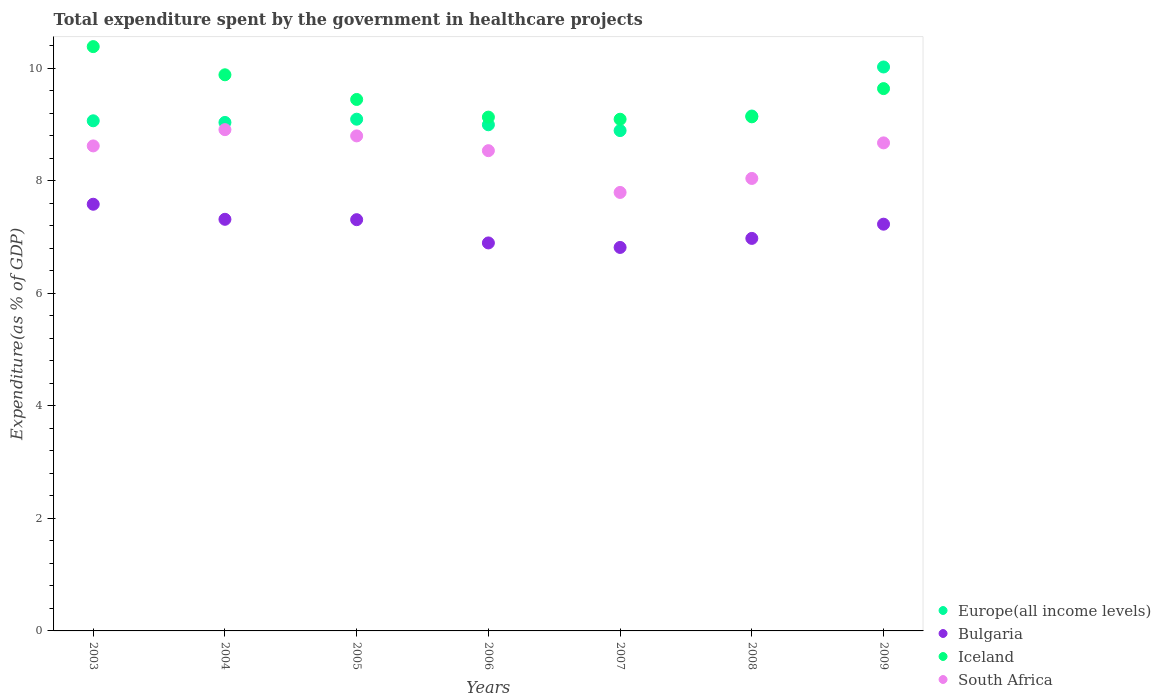How many different coloured dotlines are there?
Provide a succinct answer. 4. Is the number of dotlines equal to the number of legend labels?
Give a very brief answer. Yes. What is the total expenditure spent by the government in healthcare projects in Europe(all income levels) in 2005?
Your answer should be compact. 9.09. Across all years, what is the maximum total expenditure spent by the government in healthcare projects in Iceland?
Your response must be concise. 10.38. Across all years, what is the minimum total expenditure spent by the government in healthcare projects in South Africa?
Your response must be concise. 7.79. In which year was the total expenditure spent by the government in healthcare projects in Bulgaria maximum?
Ensure brevity in your answer.  2003. What is the total total expenditure spent by the government in healthcare projects in South Africa in the graph?
Provide a succinct answer. 59.35. What is the difference between the total expenditure spent by the government in healthcare projects in Europe(all income levels) in 2004 and that in 2008?
Your answer should be compact. -0.11. What is the difference between the total expenditure spent by the government in healthcare projects in South Africa in 2005 and the total expenditure spent by the government in healthcare projects in Iceland in 2009?
Provide a succinct answer. -0.84. What is the average total expenditure spent by the government in healthcare projects in South Africa per year?
Your response must be concise. 8.48. In the year 2007, what is the difference between the total expenditure spent by the government in healthcare projects in Bulgaria and total expenditure spent by the government in healthcare projects in Iceland?
Ensure brevity in your answer.  -2.28. In how many years, is the total expenditure spent by the government in healthcare projects in Iceland greater than 6.4 %?
Provide a short and direct response. 7. What is the ratio of the total expenditure spent by the government in healthcare projects in Europe(all income levels) in 2003 to that in 2005?
Provide a succinct answer. 1. What is the difference between the highest and the second highest total expenditure spent by the government in healthcare projects in Europe(all income levels)?
Ensure brevity in your answer.  0.87. What is the difference between the highest and the lowest total expenditure spent by the government in healthcare projects in Bulgaria?
Offer a terse response. 0.77. In how many years, is the total expenditure spent by the government in healthcare projects in Iceland greater than the average total expenditure spent by the government in healthcare projects in Iceland taken over all years?
Offer a very short reply. 3. Is it the case that in every year, the sum of the total expenditure spent by the government in healthcare projects in Bulgaria and total expenditure spent by the government in healthcare projects in Iceland  is greater than the sum of total expenditure spent by the government in healthcare projects in Europe(all income levels) and total expenditure spent by the government in healthcare projects in South Africa?
Offer a very short reply. No. Does the total expenditure spent by the government in healthcare projects in Europe(all income levels) monotonically increase over the years?
Provide a short and direct response. No. Is the total expenditure spent by the government in healthcare projects in Europe(all income levels) strictly greater than the total expenditure spent by the government in healthcare projects in South Africa over the years?
Your answer should be very brief. Yes. Is the total expenditure spent by the government in healthcare projects in Bulgaria strictly less than the total expenditure spent by the government in healthcare projects in South Africa over the years?
Make the answer very short. Yes. What is the difference between two consecutive major ticks on the Y-axis?
Offer a terse response. 2. Does the graph contain any zero values?
Offer a terse response. No. Where does the legend appear in the graph?
Your answer should be very brief. Bottom right. What is the title of the graph?
Your response must be concise. Total expenditure spent by the government in healthcare projects. Does "Latin America(all income levels)" appear as one of the legend labels in the graph?
Your answer should be very brief. No. What is the label or title of the X-axis?
Your answer should be compact. Years. What is the label or title of the Y-axis?
Make the answer very short. Expenditure(as % of GDP). What is the Expenditure(as % of GDP) of Europe(all income levels) in 2003?
Offer a very short reply. 9.06. What is the Expenditure(as % of GDP) of Bulgaria in 2003?
Ensure brevity in your answer.  7.58. What is the Expenditure(as % of GDP) in Iceland in 2003?
Ensure brevity in your answer.  10.38. What is the Expenditure(as % of GDP) of South Africa in 2003?
Ensure brevity in your answer.  8.62. What is the Expenditure(as % of GDP) in Europe(all income levels) in 2004?
Your answer should be compact. 9.03. What is the Expenditure(as % of GDP) of Bulgaria in 2004?
Offer a terse response. 7.31. What is the Expenditure(as % of GDP) in Iceland in 2004?
Ensure brevity in your answer.  9.88. What is the Expenditure(as % of GDP) of South Africa in 2004?
Offer a very short reply. 8.91. What is the Expenditure(as % of GDP) of Europe(all income levels) in 2005?
Provide a succinct answer. 9.09. What is the Expenditure(as % of GDP) of Bulgaria in 2005?
Provide a short and direct response. 7.31. What is the Expenditure(as % of GDP) in Iceland in 2005?
Provide a short and direct response. 9.44. What is the Expenditure(as % of GDP) in South Africa in 2005?
Provide a succinct answer. 8.8. What is the Expenditure(as % of GDP) of Europe(all income levels) in 2006?
Offer a terse response. 8.99. What is the Expenditure(as % of GDP) of Bulgaria in 2006?
Give a very brief answer. 6.89. What is the Expenditure(as % of GDP) of Iceland in 2006?
Provide a short and direct response. 9.13. What is the Expenditure(as % of GDP) in South Africa in 2006?
Give a very brief answer. 8.53. What is the Expenditure(as % of GDP) of Europe(all income levels) in 2007?
Your answer should be compact. 8.89. What is the Expenditure(as % of GDP) in Bulgaria in 2007?
Keep it short and to the point. 6.81. What is the Expenditure(as % of GDP) of Iceland in 2007?
Make the answer very short. 9.09. What is the Expenditure(as % of GDP) in South Africa in 2007?
Offer a terse response. 7.79. What is the Expenditure(as % of GDP) in Europe(all income levels) in 2008?
Provide a succinct answer. 9.15. What is the Expenditure(as % of GDP) in Bulgaria in 2008?
Your answer should be very brief. 6.97. What is the Expenditure(as % of GDP) in Iceland in 2008?
Ensure brevity in your answer.  9.13. What is the Expenditure(as % of GDP) in South Africa in 2008?
Your answer should be compact. 8.04. What is the Expenditure(as % of GDP) of Europe(all income levels) in 2009?
Provide a succinct answer. 10.02. What is the Expenditure(as % of GDP) of Bulgaria in 2009?
Your answer should be very brief. 7.23. What is the Expenditure(as % of GDP) of Iceland in 2009?
Offer a very short reply. 9.64. What is the Expenditure(as % of GDP) in South Africa in 2009?
Make the answer very short. 8.67. Across all years, what is the maximum Expenditure(as % of GDP) in Europe(all income levels)?
Your answer should be compact. 10.02. Across all years, what is the maximum Expenditure(as % of GDP) in Bulgaria?
Offer a very short reply. 7.58. Across all years, what is the maximum Expenditure(as % of GDP) of Iceland?
Ensure brevity in your answer.  10.38. Across all years, what is the maximum Expenditure(as % of GDP) in South Africa?
Keep it short and to the point. 8.91. Across all years, what is the minimum Expenditure(as % of GDP) of Europe(all income levels)?
Ensure brevity in your answer.  8.89. Across all years, what is the minimum Expenditure(as % of GDP) of Bulgaria?
Provide a short and direct response. 6.81. Across all years, what is the minimum Expenditure(as % of GDP) of Iceland?
Provide a succinct answer. 9.09. Across all years, what is the minimum Expenditure(as % of GDP) in South Africa?
Give a very brief answer. 7.79. What is the total Expenditure(as % of GDP) of Europe(all income levels) in the graph?
Your answer should be compact. 64.24. What is the total Expenditure(as % of GDP) in Bulgaria in the graph?
Your answer should be compact. 50.11. What is the total Expenditure(as % of GDP) of Iceland in the graph?
Give a very brief answer. 66.7. What is the total Expenditure(as % of GDP) in South Africa in the graph?
Provide a succinct answer. 59.35. What is the difference between the Expenditure(as % of GDP) of Europe(all income levels) in 2003 and that in 2004?
Your answer should be very brief. 0.03. What is the difference between the Expenditure(as % of GDP) of Bulgaria in 2003 and that in 2004?
Give a very brief answer. 0.27. What is the difference between the Expenditure(as % of GDP) in Iceland in 2003 and that in 2004?
Your answer should be compact. 0.5. What is the difference between the Expenditure(as % of GDP) in South Africa in 2003 and that in 2004?
Keep it short and to the point. -0.29. What is the difference between the Expenditure(as % of GDP) in Europe(all income levels) in 2003 and that in 2005?
Offer a terse response. -0.03. What is the difference between the Expenditure(as % of GDP) of Bulgaria in 2003 and that in 2005?
Offer a terse response. 0.27. What is the difference between the Expenditure(as % of GDP) of Iceland in 2003 and that in 2005?
Give a very brief answer. 0.94. What is the difference between the Expenditure(as % of GDP) of South Africa in 2003 and that in 2005?
Offer a terse response. -0.18. What is the difference between the Expenditure(as % of GDP) in Europe(all income levels) in 2003 and that in 2006?
Give a very brief answer. 0.07. What is the difference between the Expenditure(as % of GDP) in Bulgaria in 2003 and that in 2006?
Your response must be concise. 0.69. What is the difference between the Expenditure(as % of GDP) of Iceland in 2003 and that in 2006?
Keep it short and to the point. 1.25. What is the difference between the Expenditure(as % of GDP) of South Africa in 2003 and that in 2006?
Your answer should be very brief. 0.08. What is the difference between the Expenditure(as % of GDP) in Europe(all income levels) in 2003 and that in 2007?
Ensure brevity in your answer.  0.17. What is the difference between the Expenditure(as % of GDP) in Bulgaria in 2003 and that in 2007?
Provide a short and direct response. 0.77. What is the difference between the Expenditure(as % of GDP) of Iceland in 2003 and that in 2007?
Give a very brief answer. 1.29. What is the difference between the Expenditure(as % of GDP) in South Africa in 2003 and that in 2007?
Offer a very short reply. 0.83. What is the difference between the Expenditure(as % of GDP) in Europe(all income levels) in 2003 and that in 2008?
Offer a very short reply. -0.08. What is the difference between the Expenditure(as % of GDP) of Bulgaria in 2003 and that in 2008?
Ensure brevity in your answer.  0.61. What is the difference between the Expenditure(as % of GDP) of Iceland in 2003 and that in 2008?
Provide a short and direct response. 1.25. What is the difference between the Expenditure(as % of GDP) in South Africa in 2003 and that in 2008?
Your response must be concise. 0.58. What is the difference between the Expenditure(as % of GDP) of Europe(all income levels) in 2003 and that in 2009?
Make the answer very short. -0.96. What is the difference between the Expenditure(as % of GDP) in Bulgaria in 2003 and that in 2009?
Your answer should be compact. 0.35. What is the difference between the Expenditure(as % of GDP) of Iceland in 2003 and that in 2009?
Give a very brief answer. 0.75. What is the difference between the Expenditure(as % of GDP) of South Africa in 2003 and that in 2009?
Offer a very short reply. -0.05. What is the difference between the Expenditure(as % of GDP) in Europe(all income levels) in 2004 and that in 2005?
Provide a short and direct response. -0.06. What is the difference between the Expenditure(as % of GDP) of Bulgaria in 2004 and that in 2005?
Provide a succinct answer. 0.01. What is the difference between the Expenditure(as % of GDP) of Iceland in 2004 and that in 2005?
Provide a succinct answer. 0.44. What is the difference between the Expenditure(as % of GDP) of South Africa in 2004 and that in 2005?
Keep it short and to the point. 0.11. What is the difference between the Expenditure(as % of GDP) in Europe(all income levels) in 2004 and that in 2006?
Provide a short and direct response. 0.04. What is the difference between the Expenditure(as % of GDP) in Bulgaria in 2004 and that in 2006?
Your answer should be compact. 0.42. What is the difference between the Expenditure(as % of GDP) of Iceland in 2004 and that in 2006?
Ensure brevity in your answer.  0.75. What is the difference between the Expenditure(as % of GDP) of South Africa in 2004 and that in 2006?
Your response must be concise. 0.37. What is the difference between the Expenditure(as % of GDP) in Europe(all income levels) in 2004 and that in 2007?
Offer a terse response. 0.14. What is the difference between the Expenditure(as % of GDP) of Bulgaria in 2004 and that in 2007?
Your response must be concise. 0.5. What is the difference between the Expenditure(as % of GDP) in Iceland in 2004 and that in 2007?
Offer a terse response. 0.79. What is the difference between the Expenditure(as % of GDP) of South Africa in 2004 and that in 2007?
Your answer should be compact. 1.12. What is the difference between the Expenditure(as % of GDP) of Europe(all income levels) in 2004 and that in 2008?
Give a very brief answer. -0.11. What is the difference between the Expenditure(as % of GDP) in Bulgaria in 2004 and that in 2008?
Ensure brevity in your answer.  0.34. What is the difference between the Expenditure(as % of GDP) in Iceland in 2004 and that in 2008?
Keep it short and to the point. 0.75. What is the difference between the Expenditure(as % of GDP) in South Africa in 2004 and that in 2008?
Your response must be concise. 0.87. What is the difference between the Expenditure(as % of GDP) in Europe(all income levels) in 2004 and that in 2009?
Offer a terse response. -0.99. What is the difference between the Expenditure(as % of GDP) of Bulgaria in 2004 and that in 2009?
Your response must be concise. 0.09. What is the difference between the Expenditure(as % of GDP) in Iceland in 2004 and that in 2009?
Provide a short and direct response. 0.25. What is the difference between the Expenditure(as % of GDP) of South Africa in 2004 and that in 2009?
Ensure brevity in your answer.  0.23. What is the difference between the Expenditure(as % of GDP) of Europe(all income levels) in 2005 and that in 2006?
Provide a succinct answer. 0.1. What is the difference between the Expenditure(as % of GDP) of Bulgaria in 2005 and that in 2006?
Offer a terse response. 0.41. What is the difference between the Expenditure(as % of GDP) in Iceland in 2005 and that in 2006?
Give a very brief answer. 0.31. What is the difference between the Expenditure(as % of GDP) of South Africa in 2005 and that in 2006?
Offer a terse response. 0.26. What is the difference between the Expenditure(as % of GDP) of Europe(all income levels) in 2005 and that in 2007?
Give a very brief answer. 0.2. What is the difference between the Expenditure(as % of GDP) in Bulgaria in 2005 and that in 2007?
Provide a short and direct response. 0.49. What is the difference between the Expenditure(as % of GDP) in Iceland in 2005 and that in 2007?
Offer a terse response. 0.35. What is the difference between the Expenditure(as % of GDP) of South Africa in 2005 and that in 2007?
Make the answer very short. 1. What is the difference between the Expenditure(as % of GDP) in Europe(all income levels) in 2005 and that in 2008?
Offer a very short reply. -0.06. What is the difference between the Expenditure(as % of GDP) in Bulgaria in 2005 and that in 2008?
Make the answer very short. 0.33. What is the difference between the Expenditure(as % of GDP) of Iceland in 2005 and that in 2008?
Provide a short and direct response. 0.31. What is the difference between the Expenditure(as % of GDP) in South Africa in 2005 and that in 2008?
Your response must be concise. 0.76. What is the difference between the Expenditure(as % of GDP) in Europe(all income levels) in 2005 and that in 2009?
Ensure brevity in your answer.  -0.93. What is the difference between the Expenditure(as % of GDP) of Iceland in 2005 and that in 2009?
Your response must be concise. -0.19. What is the difference between the Expenditure(as % of GDP) of South Africa in 2005 and that in 2009?
Your response must be concise. 0.12. What is the difference between the Expenditure(as % of GDP) of Europe(all income levels) in 2006 and that in 2007?
Your answer should be very brief. 0.1. What is the difference between the Expenditure(as % of GDP) in Bulgaria in 2006 and that in 2007?
Your answer should be compact. 0.08. What is the difference between the Expenditure(as % of GDP) of Iceland in 2006 and that in 2007?
Keep it short and to the point. 0.04. What is the difference between the Expenditure(as % of GDP) in South Africa in 2006 and that in 2007?
Offer a terse response. 0.74. What is the difference between the Expenditure(as % of GDP) in Europe(all income levels) in 2006 and that in 2008?
Your answer should be very brief. -0.16. What is the difference between the Expenditure(as % of GDP) of Bulgaria in 2006 and that in 2008?
Your response must be concise. -0.08. What is the difference between the Expenditure(as % of GDP) of Iceland in 2006 and that in 2008?
Your response must be concise. -0.01. What is the difference between the Expenditure(as % of GDP) in South Africa in 2006 and that in 2008?
Provide a succinct answer. 0.49. What is the difference between the Expenditure(as % of GDP) of Europe(all income levels) in 2006 and that in 2009?
Ensure brevity in your answer.  -1.03. What is the difference between the Expenditure(as % of GDP) of Iceland in 2006 and that in 2009?
Offer a very short reply. -0.51. What is the difference between the Expenditure(as % of GDP) of South Africa in 2006 and that in 2009?
Offer a very short reply. -0.14. What is the difference between the Expenditure(as % of GDP) in Europe(all income levels) in 2007 and that in 2008?
Give a very brief answer. -0.26. What is the difference between the Expenditure(as % of GDP) in Bulgaria in 2007 and that in 2008?
Make the answer very short. -0.16. What is the difference between the Expenditure(as % of GDP) in Iceland in 2007 and that in 2008?
Your response must be concise. -0.04. What is the difference between the Expenditure(as % of GDP) of South Africa in 2007 and that in 2008?
Offer a very short reply. -0.25. What is the difference between the Expenditure(as % of GDP) in Europe(all income levels) in 2007 and that in 2009?
Keep it short and to the point. -1.13. What is the difference between the Expenditure(as % of GDP) of Bulgaria in 2007 and that in 2009?
Ensure brevity in your answer.  -0.41. What is the difference between the Expenditure(as % of GDP) in Iceland in 2007 and that in 2009?
Offer a terse response. -0.54. What is the difference between the Expenditure(as % of GDP) in South Africa in 2007 and that in 2009?
Make the answer very short. -0.88. What is the difference between the Expenditure(as % of GDP) of Europe(all income levels) in 2008 and that in 2009?
Provide a short and direct response. -0.87. What is the difference between the Expenditure(as % of GDP) in Bulgaria in 2008 and that in 2009?
Offer a terse response. -0.25. What is the difference between the Expenditure(as % of GDP) of Iceland in 2008 and that in 2009?
Provide a short and direct response. -0.5. What is the difference between the Expenditure(as % of GDP) in South Africa in 2008 and that in 2009?
Your response must be concise. -0.63. What is the difference between the Expenditure(as % of GDP) in Europe(all income levels) in 2003 and the Expenditure(as % of GDP) in Bulgaria in 2004?
Provide a short and direct response. 1.75. What is the difference between the Expenditure(as % of GDP) in Europe(all income levels) in 2003 and the Expenditure(as % of GDP) in Iceland in 2004?
Offer a very short reply. -0.82. What is the difference between the Expenditure(as % of GDP) in Europe(all income levels) in 2003 and the Expenditure(as % of GDP) in South Africa in 2004?
Your answer should be compact. 0.16. What is the difference between the Expenditure(as % of GDP) of Bulgaria in 2003 and the Expenditure(as % of GDP) of Iceland in 2004?
Provide a short and direct response. -2.3. What is the difference between the Expenditure(as % of GDP) in Bulgaria in 2003 and the Expenditure(as % of GDP) in South Africa in 2004?
Offer a very short reply. -1.33. What is the difference between the Expenditure(as % of GDP) of Iceland in 2003 and the Expenditure(as % of GDP) of South Africa in 2004?
Ensure brevity in your answer.  1.48. What is the difference between the Expenditure(as % of GDP) of Europe(all income levels) in 2003 and the Expenditure(as % of GDP) of Bulgaria in 2005?
Provide a short and direct response. 1.76. What is the difference between the Expenditure(as % of GDP) in Europe(all income levels) in 2003 and the Expenditure(as % of GDP) in Iceland in 2005?
Provide a short and direct response. -0.38. What is the difference between the Expenditure(as % of GDP) in Europe(all income levels) in 2003 and the Expenditure(as % of GDP) in South Africa in 2005?
Your answer should be very brief. 0.27. What is the difference between the Expenditure(as % of GDP) of Bulgaria in 2003 and the Expenditure(as % of GDP) of Iceland in 2005?
Provide a short and direct response. -1.86. What is the difference between the Expenditure(as % of GDP) of Bulgaria in 2003 and the Expenditure(as % of GDP) of South Africa in 2005?
Your answer should be very brief. -1.21. What is the difference between the Expenditure(as % of GDP) of Iceland in 2003 and the Expenditure(as % of GDP) of South Africa in 2005?
Your response must be concise. 1.59. What is the difference between the Expenditure(as % of GDP) of Europe(all income levels) in 2003 and the Expenditure(as % of GDP) of Bulgaria in 2006?
Make the answer very short. 2.17. What is the difference between the Expenditure(as % of GDP) in Europe(all income levels) in 2003 and the Expenditure(as % of GDP) in Iceland in 2006?
Provide a succinct answer. -0.07. What is the difference between the Expenditure(as % of GDP) of Europe(all income levels) in 2003 and the Expenditure(as % of GDP) of South Africa in 2006?
Make the answer very short. 0.53. What is the difference between the Expenditure(as % of GDP) in Bulgaria in 2003 and the Expenditure(as % of GDP) in Iceland in 2006?
Your answer should be very brief. -1.55. What is the difference between the Expenditure(as % of GDP) of Bulgaria in 2003 and the Expenditure(as % of GDP) of South Africa in 2006?
Your answer should be very brief. -0.95. What is the difference between the Expenditure(as % of GDP) of Iceland in 2003 and the Expenditure(as % of GDP) of South Africa in 2006?
Offer a very short reply. 1.85. What is the difference between the Expenditure(as % of GDP) of Europe(all income levels) in 2003 and the Expenditure(as % of GDP) of Bulgaria in 2007?
Ensure brevity in your answer.  2.25. What is the difference between the Expenditure(as % of GDP) of Europe(all income levels) in 2003 and the Expenditure(as % of GDP) of Iceland in 2007?
Your response must be concise. -0.03. What is the difference between the Expenditure(as % of GDP) of Europe(all income levels) in 2003 and the Expenditure(as % of GDP) of South Africa in 2007?
Your answer should be compact. 1.27. What is the difference between the Expenditure(as % of GDP) in Bulgaria in 2003 and the Expenditure(as % of GDP) in Iceland in 2007?
Provide a succinct answer. -1.51. What is the difference between the Expenditure(as % of GDP) in Bulgaria in 2003 and the Expenditure(as % of GDP) in South Africa in 2007?
Provide a short and direct response. -0.21. What is the difference between the Expenditure(as % of GDP) of Iceland in 2003 and the Expenditure(as % of GDP) of South Africa in 2007?
Give a very brief answer. 2.59. What is the difference between the Expenditure(as % of GDP) of Europe(all income levels) in 2003 and the Expenditure(as % of GDP) of Bulgaria in 2008?
Provide a succinct answer. 2.09. What is the difference between the Expenditure(as % of GDP) of Europe(all income levels) in 2003 and the Expenditure(as % of GDP) of Iceland in 2008?
Offer a terse response. -0.07. What is the difference between the Expenditure(as % of GDP) in Europe(all income levels) in 2003 and the Expenditure(as % of GDP) in South Africa in 2008?
Your answer should be very brief. 1.02. What is the difference between the Expenditure(as % of GDP) of Bulgaria in 2003 and the Expenditure(as % of GDP) of Iceland in 2008?
Offer a very short reply. -1.55. What is the difference between the Expenditure(as % of GDP) of Bulgaria in 2003 and the Expenditure(as % of GDP) of South Africa in 2008?
Give a very brief answer. -0.46. What is the difference between the Expenditure(as % of GDP) of Iceland in 2003 and the Expenditure(as % of GDP) of South Africa in 2008?
Make the answer very short. 2.34. What is the difference between the Expenditure(as % of GDP) of Europe(all income levels) in 2003 and the Expenditure(as % of GDP) of Bulgaria in 2009?
Offer a terse response. 1.84. What is the difference between the Expenditure(as % of GDP) in Europe(all income levels) in 2003 and the Expenditure(as % of GDP) in Iceland in 2009?
Your answer should be very brief. -0.57. What is the difference between the Expenditure(as % of GDP) of Europe(all income levels) in 2003 and the Expenditure(as % of GDP) of South Africa in 2009?
Keep it short and to the point. 0.39. What is the difference between the Expenditure(as % of GDP) in Bulgaria in 2003 and the Expenditure(as % of GDP) in Iceland in 2009?
Keep it short and to the point. -2.05. What is the difference between the Expenditure(as % of GDP) in Bulgaria in 2003 and the Expenditure(as % of GDP) in South Africa in 2009?
Offer a terse response. -1.09. What is the difference between the Expenditure(as % of GDP) of Iceland in 2003 and the Expenditure(as % of GDP) of South Africa in 2009?
Keep it short and to the point. 1.71. What is the difference between the Expenditure(as % of GDP) in Europe(all income levels) in 2004 and the Expenditure(as % of GDP) in Bulgaria in 2005?
Provide a succinct answer. 1.73. What is the difference between the Expenditure(as % of GDP) of Europe(all income levels) in 2004 and the Expenditure(as % of GDP) of Iceland in 2005?
Make the answer very short. -0.41. What is the difference between the Expenditure(as % of GDP) in Europe(all income levels) in 2004 and the Expenditure(as % of GDP) in South Africa in 2005?
Provide a succinct answer. 0.24. What is the difference between the Expenditure(as % of GDP) of Bulgaria in 2004 and the Expenditure(as % of GDP) of Iceland in 2005?
Offer a very short reply. -2.13. What is the difference between the Expenditure(as % of GDP) of Bulgaria in 2004 and the Expenditure(as % of GDP) of South Africa in 2005?
Offer a very short reply. -1.48. What is the difference between the Expenditure(as % of GDP) of Iceland in 2004 and the Expenditure(as % of GDP) of South Africa in 2005?
Ensure brevity in your answer.  1.09. What is the difference between the Expenditure(as % of GDP) in Europe(all income levels) in 2004 and the Expenditure(as % of GDP) in Bulgaria in 2006?
Offer a terse response. 2.14. What is the difference between the Expenditure(as % of GDP) of Europe(all income levels) in 2004 and the Expenditure(as % of GDP) of Iceland in 2006?
Provide a succinct answer. -0.09. What is the difference between the Expenditure(as % of GDP) in Europe(all income levels) in 2004 and the Expenditure(as % of GDP) in South Africa in 2006?
Your answer should be compact. 0.5. What is the difference between the Expenditure(as % of GDP) in Bulgaria in 2004 and the Expenditure(as % of GDP) in Iceland in 2006?
Ensure brevity in your answer.  -1.82. What is the difference between the Expenditure(as % of GDP) in Bulgaria in 2004 and the Expenditure(as % of GDP) in South Africa in 2006?
Keep it short and to the point. -1.22. What is the difference between the Expenditure(as % of GDP) of Iceland in 2004 and the Expenditure(as % of GDP) of South Africa in 2006?
Keep it short and to the point. 1.35. What is the difference between the Expenditure(as % of GDP) in Europe(all income levels) in 2004 and the Expenditure(as % of GDP) in Bulgaria in 2007?
Offer a very short reply. 2.22. What is the difference between the Expenditure(as % of GDP) in Europe(all income levels) in 2004 and the Expenditure(as % of GDP) in Iceland in 2007?
Make the answer very short. -0.06. What is the difference between the Expenditure(as % of GDP) in Europe(all income levels) in 2004 and the Expenditure(as % of GDP) in South Africa in 2007?
Your answer should be compact. 1.24. What is the difference between the Expenditure(as % of GDP) of Bulgaria in 2004 and the Expenditure(as % of GDP) of Iceland in 2007?
Provide a succinct answer. -1.78. What is the difference between the Expenditure(as % of GDP) in Bulgaria in 2004 and the Expenditure(as % of GDP) in South Africa in 2007?
Ensure brevity in your answer.  -0.48. What is the difference between the Expenditure(as % of GDP) in Iceland in 2004 and the Expenditure(as % of GDP) in South Africa in 2007?
Make the answer very short. 2.09. What is the difference between the Expenditure(as % of GDP) of Europe(all income levels) in 2004 and the Expenditure(as % of GDP) of Bulgaria in 2008?
Your response must be concise. 2.06. What is the difference between the Expenditure(as % of GDP) in Europe(all income levels) in 2004 and the Expenditure(as % of GDP) in Iceland in 2008?
Your answer should be very brief. -0.1. What is the difference between the Expenditure(as % of GDP) in Europe(all income levels) in 2004 and the Expenditure(as % of GDP) in South Africa in 2008?
Give a very brief answer. 1. What is the difference between the Expenditure(as % of GDP) of Bulgaria in 2004 and the Expenditure(as % of GDP) of Iceland in 2008?
Offer a terse response. -1.82. What is the difference between the Expenditure(as % of GDP) in Bulgaria in 2004 and the Expenditure(as % of GDP) in South Africa in 2008?
Ensure brevity in your answer.  -0.73. What is the difference between the Expenditure(as % of GDP) of Iceland in 2004 and the Expenditure(as % of GDP) of South Africa in 2008?
Offer a very short reply. 1.84. What is the difference between the Expenditure(as % of GDP) in Europe(all income levels) in 2004 and the Expenditure(as % of GDP) in Bulgaria in 2009?
Your answer should be compact. 1.81. What is the difference between the Expenditure(as % of GDP) in Europe(all income levels) in 2004 and the Expenditure(as % of GDP) in Iceland in 2009?
Make the answer very short. -0.6. What is the difference between the Expenditure(as % of GDP) of Europe(all income levels) in 2004 and the Expenditure(as % of GDP) of South Africa in 2009?
Offer a terse response. 0.36. What is the difference between the Expenditure(as % of GDP) of Bulgaria in 2004 and the Expenditure(as % of GDP) of Iceland in 2009?
Keep it short and to the point. -2.32. What is the difference between the Expenditure(as % of GDP) in Bulgaria in 2004 and the Expenditure(as % of GDP) in South Africa in 2009?
Your answer should be very brief. -1.36. What is the difference between the Expenditure(as % of GDP) in Iceland in 2004 and the Expenditure(as % of GDP) in South Africa in 2009?
Offer a very short reply. 1.21. What is the difference between the Expenditure(as % of GDP) in Europe(all income levels) in 2005 and the Expenditure(as % of GDP) in Bulgaria in 2006?
Your response must be concise. 2.2. What is the difference between the Expenditure(as % of GDP) in Europe(all income levels) in 2005 and the Expenditure(as % of GDP) in Iceland in 2006?
Offer a terse response. -0.04. What is the difference between the Expenditure(as % of GDP) of Europe(all income levels) in 2005 and the Expenditure(as % of GDP) of South Africa in 2006?
Provide a short and direct response. 0.56. What is the difference between the Expenditure(as % of GDP) of Bulgaria in 2005 and the Expenditure(as % of GDP) of Iceland in 2006?
Your answer should be compact. -1.82. What is the difference between the Expenditure(as % of GDP) of Bulgaria in 2005 and the Expenditure(as % of GDP) of South Africa in 2006?
Your answer should be very brief. -1.23. What is the difference between the Expenditure(as % of GDP) of Iceland in 2005 and the Expenditure(as % of GDP) of South Africa in 2006?
Give a very brief answer. 0.91. What is the difference between the Expenditure(as % of GDP) in Europe(all income levels) in 2005 and the Expenditure(as % of GDP) in Bulgaria in 2007?
Ensure brevity in your answer.  2.28. What is the difference between the Expenditure(as % of GDP) of Europe(all income levels) in 2005 and the Expenditure(as % of GDP) of Iceland in 2007?
Offer a very short reply. 0. What is the difference between the Expenditure(as % of GDP) in Europe(all income levels) in 2005 and the Expenditure(as % of GDP) in South Africa in 2007?
Provide a succinct answer. 1.3. What is the difference between the Expenditure(as % of GDP) in Bulgaria in 2005 and the Expenditure(as % of GDP) in Iceland in 2007?
Your response must be concise. -1.78. What is the difference between the Expenditure(as % of GDP) of Bulgaria in 2005 and the Expenditure(as % of GDP) of South Africa in 2007?
Your answer should be compact. -0.48. What is the difference between the Expenditure(as % of GDP) in Iceland in 2005 and the Expenditure(as % of GDP) in South Africa in 2007?
Your response must be concise. 1.65. What is the difference between the Expenditure(as % of GDP) in Europe(all income levels) in 2005 and the Expenditure(as % of GDP) in Bulgaria in 2008?
Keep it short and to the point. 2.12. What is the difference between the Expenditure(as % of GDP) of Europe(all income levels) in 2005 and the Expenditure(as % of GDP) of Iceland in 2008?
Give a very brief answer. -0.04. What is the difference between the Expenditure(as % of GDP) in Europe(all income levels) in 2005 and the Expenditure(as % of GDP) in South Africa in 2008?
Provide a succinct answer. 1.05. What is the difference between the Expenditure(as % of GDP) in Bulgaria in 2005 and the Expenditure(as % of GDP) in Iceland in 2008?
Provide a short and direct response. -1.83. What is the difference between the Expenditure(as % of GDP) in Bulgaria in 2005 and the Expenditure(as % of GDP) in South Africa in 2008?
Provide a succinct answer. -0.73. What is the difference between the Expenditure(as % of GDP) in Iceland in 2005 and the Expenditure(as % of GDP) in South Africa in 2008?
Provide a short and direct response. 1.4. What is the difference between the Expenditure(as % of GDP) in Europe(all income levels) in 2005 and the Expenditure(as % of GDP) in Bulgaria in 2009?
Keep it short and to the point. 1.87. What is the difference between the Expenditure(as % of GDP) of Europe(all income levels) in 2005 and the Expenditure(as % of GDP) of Iceland in 2009?
Give a very brief answer. -0.54. What is the difference between the Expenditure(as % of GDP) in Europe(all income levels) in 2005 and the Expenditure(as % of GDP) in South Africa in 2009?
Your response must be concise. 0.42. What is the difference between the Expenditure(as % of GDP) in Bulgaria in 2005 and the Expenditure(as % of GDP) in Iceland in 2009?
Offer a very short reply. -2.33. What is the difference between the Expenditure(as % of GDP) of Bulgaria in 2005 and the Expenditure(as % of GDP) of South Africa in 2009?
Your response must be concise. -1.36. What is the difference between the Expenditure(as % of GDP) of Iceland in 2005 and the Expenditure(as % of GDP) of South Africa in 2009?
Your answer should be very brief. 0.77. What is the difference between the Expenditure(as % of GDP) of Europe(all income levels) in 2006 and the Expenditure(as % of GDP) of Bulgaria in 2007?
Provide a short and direct response. 2.18. What is the difference between the Expenditure(as % of GDP) in Europe(all income levels) in 2006 and the Expenditure(as % of GDP) in Iceland in 2007?
Keep it short and to the point. -0.1. What is the difference between the Expenditure(as % of GDP) of Europe(all income levels) in 2006 and the Expenditure(as % of GDP) of South Africa in 2007?
Your response must be concise. 1.2. What is the difference between the Expenditure(as % of GDP) of Bulgaria in 2006 and the Expenditure(as % of GDP) of Iceland in 2007?
Keep it short and to the point. -2.2. What is the difference between the Expenditure(as % of GDP) of Bulgaria in 2006 and the Expenditure(as % of GDP) of South Africa in 2007?
Your answer should be very brief. -0.9. What is the difference between the Expenditure(as % of GDP) of Iceland in 2006 and the Expenditure(as % of GDP) of South Africa in 2007?
Your answer should be very brief. 1.34. What is the difference between the Expenditure(as % of GDP) in Europe(all income levels) in 2006 and the Expenditure(as % of GDP) in Bulgaria in 2008?
Your answer should be compact. 2.02. What is the difference between the Expenditure(as % of GDP) in Europe(all income levels) in 2006 and the Expenditure(as % of GDP) in Iceland in 2008?
Make the answer very short. -0.14. What is the difference between the Expenditure(as % of GDP) in Europe(all income levels) in 2006 and the Expenditure(as % of GDP) in South Africa in 2008?
Your answer should be compact. 0.95. What is the difference between the Expenditure(as % of GDP) of Bulgaria in 2006 and the Expenditure(as % of GDP) of Iceland in 2008?
Give a very brief answer. -2.24. What is the difference between the Expenditure(as % of GDP) of Bulgaria in 2006 and the Expenditure(as % of GDP) of South Africa in 2008?
Provide a short and direct response. -1.15. What is the difference between the Expenditure(as % of GDP) in Iceland in 2006 and the Expenditure(as % of GDP) in South Africa in 2008?
Make the answer very short. 1.09. What is the difference between the Expenditure(as % of GDP) in Europe(all income levels) in 2006 and the Expenditure(as % of GDP) in Bulgaria in 2009?
Provide a succinct answer. 1.77. What is the difference between the Expenditure(as % of GDP) in Europe(all income levels) in 2006 and the Expenditure(as % of GDP) in Iceland in 2009?
Provide a short and direct response. -0.64. What is the difference between the Expenditure(as % of GDP) in Europe(all income levels) in 2006 and the Expenditure(as % of GDP) in South Africa in 2009?
Offer a very short reply. 0.32. What is the difference between the Expenditure(as % of GDP) in Bulgaria in 2006 and the Expenditure(as % of GDP) in Iceland in 2009?
Offer a very short reply. -2.74. What is the difference between the Expenditure(as % of GDP) of Bulgaria in 2006 and the Expenditure(as % of GDP) of South Africa in 2009?
Your answer should be very brief. -1.78. What is the difference between the Expenditure(as % of GDP) in Iceland in 2006 and the Expenditure(as % of GDP) in South Africa in 2009?
Ensure brevity in your answer.  0.46. What is the difference between the Expenditure(as % of GDP) in Europe(all income levels) in 2007 and the Expenditure(as % of GDP) in Bulgaria in 2008?
Your response must be concise. 1.92. What is the difference between the Expenditure(as % of GDP) of Europe(all income levels) in 2007 and the Expenditure(as % of GDP) of Iceland in 2008?
Keep it short and to the point. -0.24. What is the difference between the Expenditure(as % of GDP) of Europe(all income levels) in 2007 and the Expenditure(as % of GDP) of South Africa in 2008?
Make the answer very short. 0.85. What is the difference between the Expenditure(as % of GDP) in Bulgaria in 2007 and the Expenditure(as % of GDP) in Iceland in 2008?
Give a very brief answer. -2.32. What is the difference between the Expenditure(as % of GDP) in Bulgaria in 2007 and the Expenditure(as % of GDP) in South Africa in 2008?
Provide a succinct answer. -1.23. What is the difference between the Expenditure(as % of GDP) in Iceland in 2007 and the Expenditure(as % of GDP) in South Africa in 2008?
Provide a short and direct response. 1.05. What is the difference between the Expenditure(as % of GDP) of Europe(all income levels) in 2007 and the Expenditure(as % of GDP) of Bulgaria in 2009?
Ensure brevity in your answer.  1.66. What is the difference between the Expenditure(as % of GDP) of Europe(all income levels) in 2007 and the Expenditure(as % of GDP) of Iceland in 2009?
Offer a very short reply. -0.75. What is the difference between the Expenditure(as % of GDP) of Europe(all income levels) in 2007 and the Expenditure(as % of GDP) of South Africa in 2009?
Provide a succinct answer. 0.22. What is the difference between the Expenditure(as % of GDP) of Bulgaria in 2007 and the Expenditure(as % of GDP) of Iceland in 2009?
Provide a succinct answer. -2.82. What is the difference between the Expenditure(as % of GDP) in Bulgaria in 2007 and the Expenditure(as % of GDP) in South Africa in 2009?
Provide a short and direct response. -1.86. What is the difference between the Expenditure(as % of GDP) in Iceland in 2007 and the Expenditure(as % of GDP) in South Africa in 2009?
Provide a succinct answer. 0.42. What is the difference between the Expenditure(as % of GDP) of Europe(all income levels) in 2008 and the Expenditure(as % of GDP) of Bulgaria in 2009?
Your answer should be very brief. 1.92. What is the difference between the Expenditure(as % of GDP) in Europe(all income levels) in 2008 and the Expenditure(as % of GDP) in Iceland in 2009?
Your response must be concise. -0.49. What is the difference between the Expenditure(as % of GDP) in Europe(all income levels) in 2008 and the Expenditure(as % of GDP) in South Africa in 2009?
Your answer should be very brief. 0.48. What is the difference between the Expenditure(as % of GDP) of Bulgaria in 2008 and the Expenditure(as % of GDP) of Iceland in 2009?
Keep it short and to the point. -2.66. What is the difference between the Expenditure(as % of GDP) of Bulgaria in 2008 and the Expenditure(as % of GDP) of South Africa in 2009?
Your answer should be very brief. -1.7. What is the difference between the Expenditure(as % of GDP) of Iceland in 2008 and the Expenditure(as % of GDP) of South Africa in 2009?
Give a very brief answer. 0.46. What is the average Expenditure(as % of GDP) of Europe(all income levels) per year?
Make the answer very short. 9.18. What is the average Expenditure(as % of GDP) of Bulgaria per year?
Provide a short and direct response. 7.16. What is the average Expenditure(as % of GDP) in Iceland per year?
Ensure brevity in your answer.  9.53. What is the average Expenditure(as % of GDP) of South Africa per year?
Your answer should be compact. 8.48. In the year 2003, what is the difference between the Expenditure(as % of GDP) in Europe(all income levels) and Expenditure(as % of GDP) in Bulgaria?
Ensure brevity in your answer.  1.48. In the year 2003, what is the difference between the Expenditure(as % of GDP) of Europe(all income levels) and Expenditure(as % of GDP) of Iceland?
Keep it short and to the point. -1.32. In the year 2003, what is the difference between the Expenditure(as % of GDP) of Europe(all income levels) and Expenditure(as % of GDP) of South Africa?
Provide a succinct answer. 0.45. In the year 2003, what is the difference between the Expenditure(as % of GDP) in Bulgaria and Expenditure(as % of GDP) in Iceland?
Keep it short and to the point. -2.8. In the year 2003, what is the difference between the Expenditure(as % of GDP) in Bulgaria and Expenditure(as % of GDP) in South Africa?
Your answer should be compact. -1.04. In the year 2003, what is the difference between the Expenditure(as % of GDP) of Iceland and Expenditure(as % of GDP) of South Africa?
Give a very brief answer. 1.76. In the year 2004, what is the difference between the Expenditure(as % of GDP) in Europe(all income levels) and Expenditure(as % of GDP) in Bulgaria?
Your answer should be very brief. 1.72. In the year 2004, what is the difference between the Expenditure(as % of GDP) in Europe(all income levels) and Expenditure(as % of GDP) in Iceland?
Ensure brevity in your answer.  -0.85. In the year 2004, what is the difference between the Expenditure(as % of GDP) of Europe(all income levels) and Expenditure(as % of GDP) of South Africa?
Offer a terse response. 0.13. In the year 2004, what is the difference between the Expenditure(as % of GDP) in Bulgaria and Expenditure(as % of GDP) in Iceland?
Ensure brevity in your answer.  -2.57. In the year 2004, what is the difference between the Expenditure(as % of GDP) in Bulgaria and Expenditure(as % of GDP) in South Africa?
Offer a very short reply. -1.59. In the year 2004, what is the difference between the Expenditure(as % of GDP) in Iceland and Expenditure(as % of GDP) in South Africa?
Keep it short and to the point. 0.97. In the year 2005, what is the difference between the Expenditure(as % of GDP) in Europe(all income levels) and Expenditure(as % of GDP) in Bulgaria?
Provide a succinct answer. 1.79. In the year 2005, what is the difference between the Expenditure(as % of GDP) in Europe(all income levels) and Expenditure(as % of GDP) in Iceland?
Provide a short and direct response. -0.35. In the year 2005, what is the difference between the Expenditure(as % of GDP) of Europe(all income levels) and Expenditure(as % of GDP) of South Africa?
Your response must be concise. 0.3. In the year 2005, what is the difference between the Expenditure(as % of GDP) in Bulgaria and Expenditure(as % of GDP) in Iceland?
Provide a succinct answer. -2.14. In the year 2005, what is the difference between the Expenditure(as % of GDP) in Bulgaria and Expenditure(as % of GDP) in South Africa?
Provide a succinct answer. -1.49. In the year 2005, what is the difference between the Expenditure(as % of GDP) of Iceland and Expenditure(as % of GDP) of South Africa?
Your answer should be very brief. 0.65. In the year 2006, what is the difference between the Expenditure(as % of GDP) in Europe(all income levels) and Expenditure(as % of GDP) in Bulgaria?
Make the answer very short. 2.1. In the year 2006, what is the difference between the Expenditure(as % of GDP) of Europe(all income levels) and Expenditure(as % of GDP) of Iceland?
Offer a terse response. -0.14. In the year 2006, what is the difference between the Expenditure(as % of GDP) of Europe(all income levels) and Expenditure(as % of GDP) of South Africa?
Make the answer very short. 0.46. In the year 2006, what is the difference between the Expenditure(as % of GDP) of Bulgaria and Expenditure(as % of GDP) of Iceland?
Offer a very short reply. -2.24. In the year 2006, what is the difference between the Expenditure(as % of GDP) in Bulgaria and Expenditure(as % of GDP) in South Africa?
Your answer should be very brief. -1.64. In the year 2006, what is the difference between the Expenditure(as % of GDP) of Iceland and Expenditure(as % of GDP) of South Africa?
Offer a terse response. 0.6. In the year 2007, what is the difference between the Expenditure(as % of GDP) of Europe(all income levels) and Expenditure(as % of GDP) of Bulgaria?
Provide a succinct answer. 2.08. In the year 2007, what is the difference between the Expenditure(as % of GDP) in Europe(all income levels) and Expenditure(as % of GDP) in Iceland?
Provide a succinct answer. -0.2. In the year 2007, what is the difference between the Expenditure(as % of GDP) in Europe(all income levels) and Expenditure(as % of GDP) in South Africa?
Provide a succinct answer. 1.1. In the year 2007, what is the difference between the Expenditure(as % of GDP) of Bulgaria and Expenditure(as % of GDP) of Iceland?
Your answer should be very brief. -2.28. In the year 2007, what is the difference between the Expenditure(as % of GDP) in Bulgaria and Expenditure(as % of GDP) in South Africa?
Your response must be concise. -0.98. In the year 2007, what is the difference between the Expenditure(as % of GDP) in Iceland and Expenditure(as % of GDP) in South Africa?
Your answer should be compact. 1.3. In the year 2008, what is the difference between the Expenditure(as % of GDP) in Europe(all income levels) and Expenditure(as % of GDP) in Bulgaria?
Offer a very short reply. 2.17. In the year 2008, what is the difference between the Expenditure(as % of GDP) in Europe(all income levels) and Expenditure(as % of GDP) in Iceland?
Offer a terse response. 0.01. In the year 2008, what is the difference between the Expenditure(as % of GDP) in Europe(all income levels) and Expenditure(as % of GDP) in South Africa?
Your response must be concise. 1.11. In the year 2008, what is the difference between the Expenditure(as % of GDP) of Bulgaria and Expenditure(as % of GDP) of Iceland?
Make the answer very short. -2.16. In the year 2008, what is the difference between the Expenditure(as % of GDP) of Bulgaria and Expenditure(as % of GDP) of South Africa?
Keep it short and to the point. -1.07. In the year 2008, what is the difference between the Expenditure(as % of GDP) of Iceland and Expenditure(as % of GDP) of South Africa?
Your answer should be very brief. 1.1. In the year 2009, what is the difference between the Expenditure(as % of GDP) of Europe(all income levels) and Expenditure(as % of GDP) of Bulgaria?
Ensure brevity in your answer.  2.79. In the year 2009, what is the difference between the Expenditure(as % of GDP) of Europe(all income levels) and Expenditure(as % of GDP) of Iceland?
Provide a succinct answer. 0.38. In the year 2009, what is the difference between the Expenditure(as % of GDP) in Europe(all income levels) and Expenditure(as % of GDP) in South Africa?
Provide a succinct answer. 1.35. In the year 2009, what is the difference between the Expenditure(as % of GDP) of Bulgaria and Expenditure(as % of GDP) of Iceland?
Keep it short and to the point. -2.41. In the year 2009, what is the difference between the Expenditure(as % of GDP) in Bulgaria and Expenditure(as % of GDP) in South Africa?
Keep it short and to the point. -1.44. In the year 2009, what is the difference between the Expenditure(as % of GDP) in Iceland and Expenditure(as % of GDP) in South Africa?
Keep it short and to the point. 0.96. What is the ratio of the Expenditure(as % of GDP) in Bulgaria in 2003 to that in 2004?
Your response must be concise. 1.04. What is the ratio of the Expenditure(as % of GDP) of Iceland in 2003 to that in 2004?
Keep it short and to the point. 1.05. What is the ratio of the Expenditure(as % of GDP) of South Africa in 2003 to that in 2004?
Offer a very short reply. 0.97. What is the ratio of the Expenditure(as % of GDP) of Bulgaria in 2003 to that in 2005?
Make the answer very short. 1.04. What is the ratio of the Expenditure(as % of GDP) in Iceland in 2003 to that in 2005?
Provide a succinct answer. 1.1. What is the ratio of the Expenditure(as % of GDP) in South Africa in 2003 to that in 2005?
Provide a succinct answer. 0.98. What is the ratio of the Expenditure(as % of GDP) of Europe(all income levels) in 2003 to that in 2006?
Provide a succinct answer. 1.01. What is the ratio of the Expenditure(as % of GDP) in Bulgaria in 2003 to that in 2006?
Give a very brief answer. 1.1. What is the ratio of the Expenditure(as % of GDP) in Iceland in 2003 to that in 2006?
Your answer should be compact. 1.14. What is the ratio of the Expenditure(as % of GDP) of South Africa in 2003 to that in 2006?
Your answer should be compact. 1.01. What is the ratio of the Expenditure(as % of GDP) in Europe(all income levels) in 2003 to that in 2007?
Make the answer very short. 1.02. What is the ratio of the Expenditure(as % of GDP) of Bulgaria in 2003 to that in 2007?
Give a very brief answer. 1.11. What is the ratio of the Expenditure(as % of GDP) of Iceland in 2003 to that in 2007?
Provide a succinct answer. 1.14. What is the ratio of the Expenditure(as % of GDP) of South Africa in 2003 to that in 2007?
Provide a succinct answer. 1.11. What is the ratio of the Expenditure(as % of GDP) in Europe(all income levels) in 2003 to that in 2008?
Your response must be concise. 0.99. What is the ratio of the Expenditure(as % of GDP) in Bulgaria in 2003 to that in 2008?
Ensure brevity in your answer.  1.09. What is the ratio of the Expenditure(as % of GDP) of Iceland in 2003 to that in 2008?
Provide a short and direct response. 1.14. What is the ratio of the Expenditure(as % of GDP) in South Africa in 2003 to that in 2008?
Keep it short and to the point. 1.07. What is the ratio of the Expenditure(as % of GDP) in Europe(all income levels) in 2003 to that in 2009?
Provide a short and direct response. 0.9. What is the ratio of the Expenditure(as % of GDP) of Bulgaria in 2003 to that in 2009?
Your response must be concise. 1.05. What is the ratio of the Expenditure(as % of GDP) of Iceland in 2003 to that in 2009?
Offer a very short reply. 1.08. What is the ratio of the Expenditure(as % of GDP) of South Africa in 2003 to that in 2009?
Give a very brief answer. 0.99. What is the ratio of the Expenditure(as % of GDP) of Bulgaria in 2004 to that in 2005?
Provide a short and direct response. 1. What is the ratio of the Expenditure(as % of GDP) in Iceland in 2004 to that in 2005?
Provide a succinct answer. 1.05. What is the ratio of the Expenditure(as % of GDP) in South Africa in 2004 to that in 2005?
Ensure brevity in your answer.  1.01. What is the ratio of the Expenditure(as % of GDP) in Europe(all income levels) in 2004 to that in 2006?
Ensure brevity in your answer.  1. What is the ratio of the Expenditure(as % of GDP) of Bulgaria in 2004 to that in 2006?
Offer a terse response. 1.06. What is the ratio of the Expenditure(as % of GDP) of Iceland in 2004 to that in 2006?
Provide a short and direct response. 1.08. What is the ratio of the Expenditure(as % of GDP) in South Africa in 2004 to that in 2006?
Your answer should be very brief. 1.04. What is the ratio of the Expenditure(as % of GDP) of Europe(all income levels) in 2004 to that in 2007?
Keep it short and to the point. 1.02. What is the ratio of the Expenditure(as % of GDP) in Bulgaria in 2004 to that in 2007?
Provide a short and direct response. 1.07. What is the ratio of the Expenditure(as % of GDP) of Iceland in 2004 to that in 2007?
Your answer should be very brief. 1.09. What is the ratio of the Expenditure(as % of GDP) in South Africa in 2004 to that in 2007?
Provide a succinct answer. 1.14. What is the ratio of the Expenditure(as % of GDP) in Europe(all income levels) in 2004 to that in 2008?
Provide a succinct answer. 0.99. What is the ratio of the Expenditure(as % of GDP) in Bulgaria in 2004 to that in 2008?
Your answer should be very brief. 1.05. What is the ratio of the Expenditure(as % of GDP) of Iceland in 2004 to that in 2008?
Your response must be concise. 1.08. What is the ratio of the Expenditure(as % of GDP) of South Africa in 2004 to that in 2008?
Provide a succinct answer. 1.11. What is the ratio of the Expenditure(as % of GDP) in Europe(all income levels) in 2004 to that in 2009?
Offer a terse response. 0.9. What is the ratio of the Expenditure(as % of GDP) in Bulgaria in 2004 to that in 2009?
Provide a short and direct response. 1.01. What is the ratio of the Expenditure(as % of GDP) of Iceland in 2004 to that in 2009?
Provide a succinct answer. 1.03. What is the ratio of the Expenditure(as % of GDP) of South Africa in 2004 to that in 2009?
Offer a very short reply. 1.03. What is the ratio of the Expenditure(as % of GDP) in Bulgaria in 2005 to that in 2006?
Provide a succinct answer. 1.06. What is the ratio of the Expenditure(as % of GDP) in Iceland in 2005 to that in 2006?
Your response must be concise. 1.03. What is the ratio of the Expenditure(as % of GDP) in South Africa in 2005 to that in 2006?
Your answer should be compact. 1.03. What is the ratio of the Expenditure(as % of GDP) of Europe(all income levels) in 2005 to that in 2007?
Your answer should be very brief. 1.02. What is the ratio of the Expenditure(as % of GDP) of Bulgaria in 2005 to that in 2007?
Make the answer very short. 1.07. What is the ratio of the Expenditure(as % of GDP) of Iceland in 2005 to that in 2007?
Your answer should be compact. 1.04. What is the ratio of the Expenditure(as % of GDP) in South Africa in 2005 to that in 2007?
Your answer should be very brief. 1.13. What is the ratio of the Expenditure(as % of GDP) of Bulgaria in 2005 to that in 2008?
Your answer should be compact. 1.05. What is the ratio of the Expenditure(as % of GDP) in Iceland in 2005 to that in 2008?
Provide a succinct answer. 1.03. What is the ratio of the Expenditure(as % of GDP) in South Africa in 2005 to that in 2008?
Give a very brief answer. 1.09. What is the ratio of the Expenditure(as % of GDP) in Europe(all income levels) in 2005 to that in 2009?
Your answer should be compact. 0.91. What is the ratio of the Expenditure(as % of GDP) of Bulgaria in 2005 to that in 2009?
Keep it short and to the point. 1.01. What is the ratio of the Expenditure(as % of GDP) of South Africa in 2005 to that in 2009?
Make the answer very short. 1.01. What is the ratio of the Expenditure(as % of GDP) of Europe(all income levels) in 2006 to that in 2007?
Give a very brief answer. 1.01. What is the ratio of the Expenditure(as % of GDP) in Bulgaria in 2006 to that in 2007?
Your response must be concise. 1.01. What is the ratio of the Expenditure(as % of GDP) in South Africa in 2006 to that in 2007?
Offer a very short reply. 1.1. What is the ratio of the Expenditure(as % of GDP) in Europe(all income levels) in 2006 to that in 2008?
Ensure brevity in your answer.  0.98. What is the ratio of the Expenditure(as % of GDP) of Bulgaria in 2006 to that in 2008?
Offer a terse response. 0.99. What is the ratio of the Expenditure(as % of GDP) in South Africa in 2006 to that in 2008?
Your answer should be compact. 1.06. What is the ratio of the Expenditure(as % of GDP) of Europe(all income levels) in 2006 to that in 2009?
Make the answer very short. 0.9. What is the ratio of the Expenditure(as % of GDP) of Bulgaria in 2006 to that in 2009?
Give a very brief answer. 0.95. What is the ratio of the Expenditure(as % of GDP) in Iceland in 2006 to that in 2009?
Keep it short and to the point. 0.95. What is the ratio of the Expenditure(as % of GDP) of South Africa in 2006 to that in 2009?
Your answer should be very brief. 0.98. What is the ratio of the Expenditure(as % of GDP) of Europe(all income levels) in 2007 to that in 2008?
Ensure brevity in your answer.  0.97. What is the ratio of the Expenditure(as % of GDP) of Bulgaria in 2007 to that in 2008?
Ensure brevity in your answer.  0.98. What is the ratio of the Expenditure(as % of GDP) in South Africa in 2007 to that in 2008?
Provide a short and direct response. 0.97. What is the ratio of the Expenditure(as % of GDP) of Europe(all income levels) in 2007 to that in 2009?
Give a very brief answer. 0.89. What is the ratio of the Expenditure(as % of GDP) of Bulgaria in 2007 to that in 2009?
Provide a short and direct response. 0.94. What is the ratio of the Expenditure(as % of GDP) in Iceland in 2007 to that in 2009?
Keep it short and to the point. 0.94. What is the ratio of the Expenditure(as % of GDP) of South Africa in 2007 to that in 2009?
Provide a succinct answer. 0.9. What is the ratio of the Expenditure(as % of GDP) of Europe(all income levels) in 2008 to that in 2009?
Provide a short and direct response. 0.91. What is the ratio of the Expenditure(as % of GDP) in Iceland in 2008 to that in 2009?
Your answer should be compact. 0.95. What is the ratio of the Expenditure(as % of GDP) of South Africa in 2008 to that in 2009?
Make the answer very short. 0.93. What is the difference between the highest and the second highest Expenditure(as % of GDP) of Europe(all income levels)?
Offer a terse response. 0.87. What is the difference between the highest and the second highest Expenditure(as % of GDP) of Bulgaria?
Give a very brief answer. 0.27. What is the difference between the highest and the second highest Expenditure(as % of GDP) in Iceland?
Your answer should be compact. 0.5. What is the difference between the highest and the second highest Expenditure(as % of GDP) in South Africa?
Your answer should be very brief. 0.11. What is the difference between the highest and the lowest Expenditure(as % of GDP) in Europe(all income levels)?
Ensure brevity in your answer.  1.13. What is the difference between the highest and the lowest Expenditure(as % of GDP) of Bulgaria?
Keep it short and to the point. 0.77. What is the difference between the highest and the lowest Expenditure(as % of GDP) in Iceland?
Provide a short and direct response. 1.29. What is the difference between the highest and the lowest Expenditure(as % of GDP) in South Africa?
Your response must be concise. 1.12. 